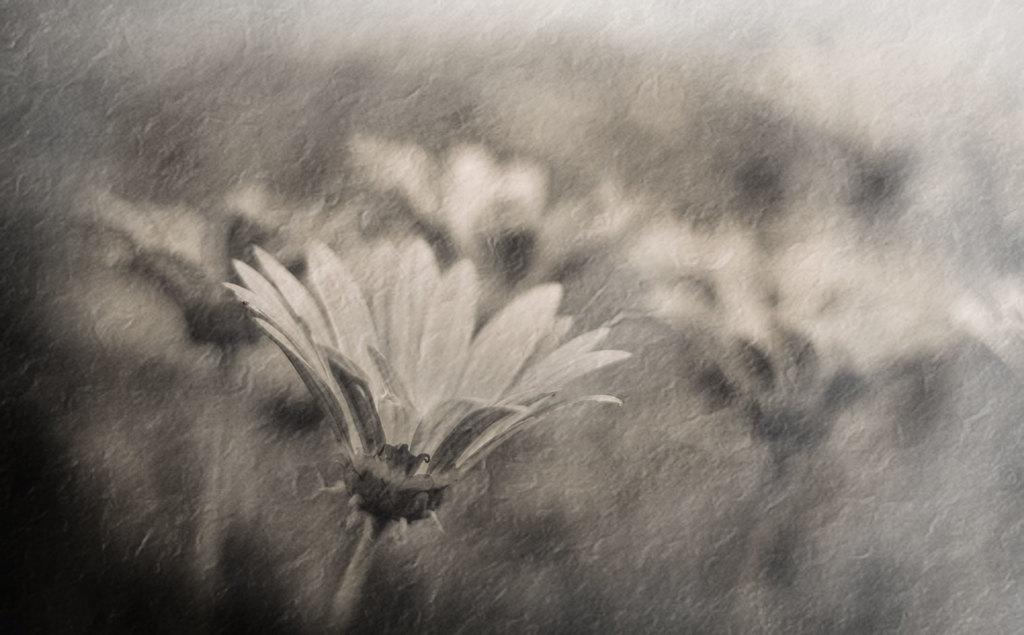What type of living organisms can be seen in the image? There are flowers in the image. Can you describe the background of the image? The background of the image is blurry. What type of wine is being exchanged in the image? There is no wine or exchange of any kind present in the image; it only features flowers and a blurry background. 